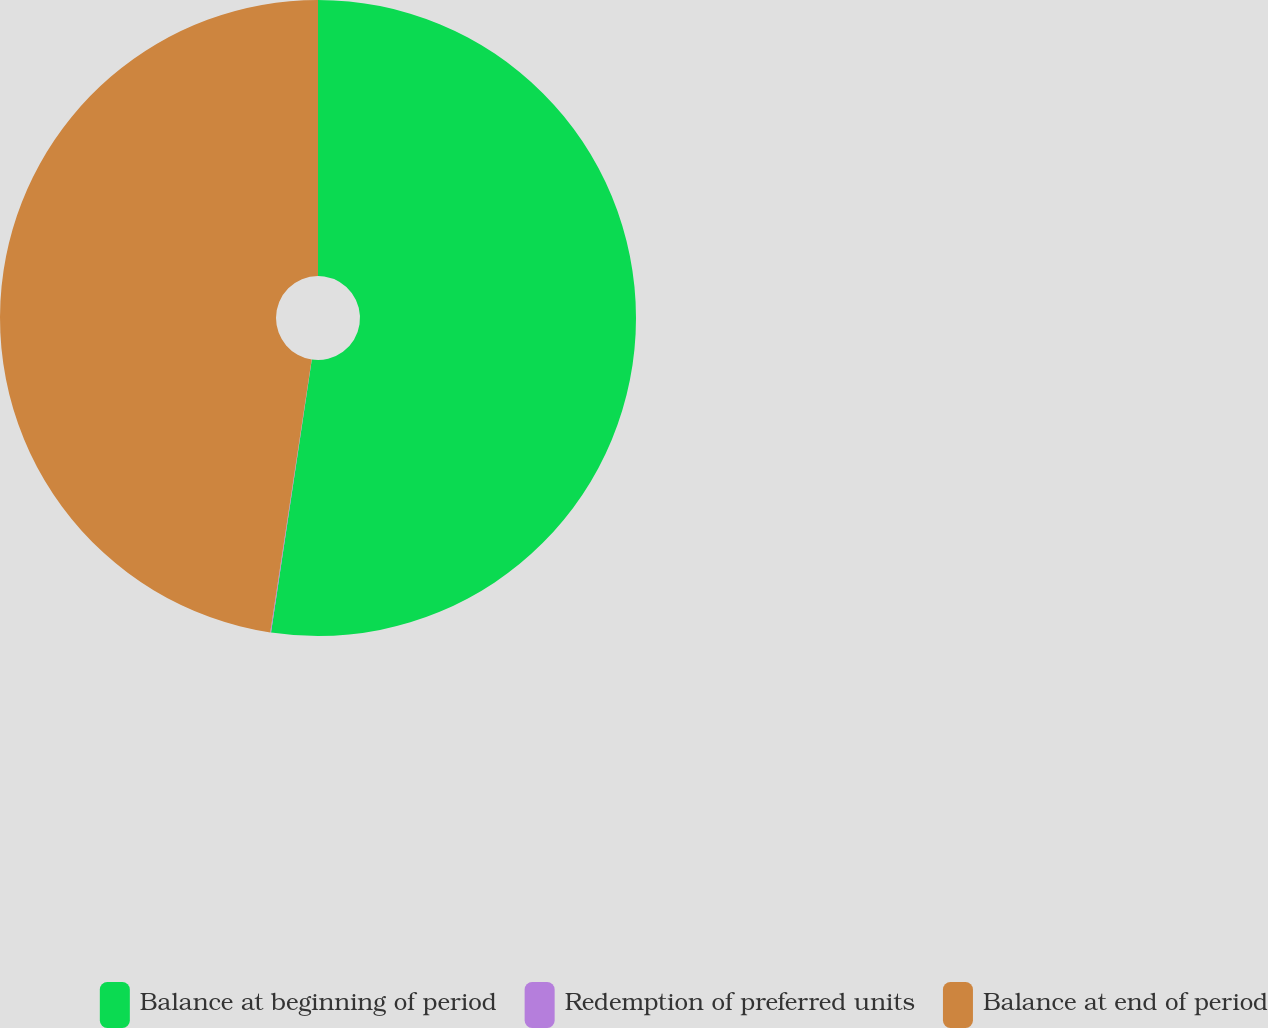Convert chart to OTSL. <chart><loc_0><loc_0><loc_500><loc_500><pie_chart><fcel>Balance at beginning of period<fcel>Redemption of preferred units<fcel>Balance at end of period<nl><fcel>52.36%<fcel>0.04%<fcel>47.6%<nl></chart> 